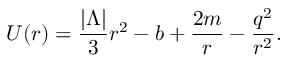Convert formula to latex. <formula><loc_0><loc_0><loc_500><loc_500>U ( r ) = \frac { | \Lambda | } { 3 } r ^ { 2 } - b + \frac { 2 m } { r } - \frac { q ^ { 2 } } { r ^ { 2 } } .</formula> 